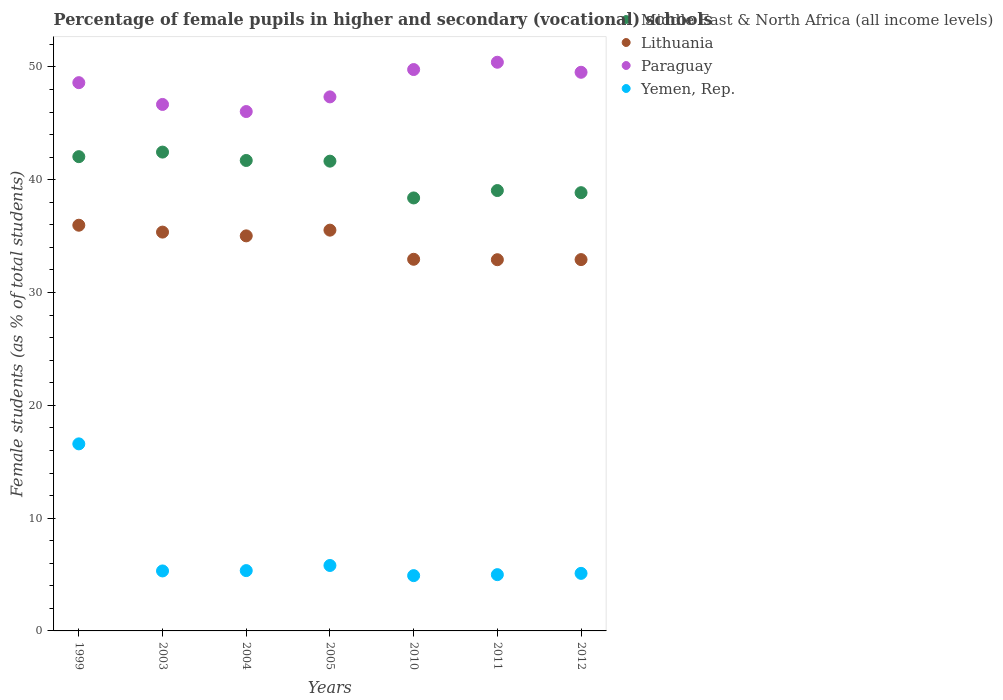What is the percentage of female pupils in higher and secondary schools in Middle East & North Africa (all income levels) in 2003?
Ensure brevity in your answer.  42.45. Across all years, what is the maximum percentage of female pupils in higher and secondary schools in Yemen, Rep.?
Offer a terse response. 16.58. Across all years, what is the minimum percentage of female pupils in higher and secondary schools in Middle East & North Africa (all income levels)?
Your answer should be compact. 38.39. In which year was the percentage of female pupils in higher and secondary schools in Lithuania minimum?
Keep it short and to the point. 2011. What is the total percentage of female pupils in higher and secondary schools in Lithuania in the graph?
Give a very brief answer. 240.66. What is the difference between the percentage of female pupils in higher and secondary schools in Middle East & North Africa (all income levels) in 2003 and that in 2011?
Provide a short and direct response. 3.41. What is the difference between the percentage of female pupils in higher and secondary schools in Middle East & North Africa (all income levels) in 1999 and the percentage of female pupils in higher and secondary schools in Paraguay in 2010?
Make the answer very short. -7.72. What is the average percentage of female pupils in higher and secondary schools in Middle East & North Africa (all income levels) per year?
Your response must be concise. 40.59. In the year 2003, what is the difference between the percentage of female pupils in higher and secondary schools in Middle East & North Africa (all income levels) and percentage of female pupils in higher and secondary schools in Paraguay?
Your answer should be very brief. -4.22. In how many years, is the percentage of female pupils in higher and secondary schools in Lithuania greater than 40 %?
Give a very brief answer. 0. What is the ratio of the percentage of female pupils in higher and secondary schools in Middle East & North Africa (all income levels) in 2003 to that in 2012?
Offer a terse response. 1.09. Is the percentage of female pupils in higher and secondary schools in Middle East & North Africa (all income levels) in 2003 less than that in 2005?
Ensure brevity in your answer.  No. What is the difference between the highest and the second highest percentage of female pupils in higher and secondary schools in Lithuania?
Make the answer very short. 0.44. What is the difference between the highest and the lowest percentage of female pupils in higher and secondary schools in Paraguay?
Make the answer very short. 4.37. Is it the case that in every year, the sum of the percentage of female pupils in higher and secondary schools in Middle East & North Africa (all income levels) and percentage of female pupils in higher and secondary schools in Lithuania  is greater than the sum of percentage of female pupils in higher and secondary schools in Yemen, Rep. and percentage of female pupils in higher and secondary schools in Paraguay?
Offer a terse response. No. Does the percentage of female pupils in higher and secondary schools in Lithuania monotonically increase over the years?
Provide a succinct answer. No. Is the percentage of female pupils in higher and secondary schools in Middle East & North Africa (all income levels) strictly greater than the percentage of female pupils in higher and secondary schools in Lithuania over the years?
Keep it short and to the point. Yes. How many years are there in the graph?
Offer a very short reply. 7. Does the graph contain any zero values?
Keep it short and to the point. No. Does the graph contain grids?
Offer a very short reply. No. Where does the legend appear in the graph?
Offer a terse response. Top right. How many legend labels are there?
Give a very brief answer. 4. How are the legend labels stacked?
Give a very brief answer. Vertical. What is the title of the graph?
Offer a very short reply. Percentage of female pupils in higher and secondary (vocational) schools. Does "Mexico" appear as one of the legend labels in the graph?
Your response must be concise. No. What is the label or title of the X-axis?
Provide a short and direct response. Years. What is the label or title of the Y-axis?
Your response must be concise. Female students (as % of total students). What is the Female students (as % of total students) of Middle East & North Africa (all income levels) in 1999?
Ensure brevity in your answer.  42.05. What is the Female students (as % of total students) in Lithuania in 1999?
Offer a terse response. 35.97. What is the Female students (as % of total students) of Paraguay in 1999?
Keep it short and to the point. 48.61. What is the Female students (as % of total students) of Yemen, Rep. in 1999?
Give a very brief answer. 16.58. What is the Female students (as % of total students) of Middle East & North Africa (all income levels) in 2003?
Give a very brief answer. 42.45. What is the Female students (as % of total students) of Lithuania in 2003?
Offer a terse response. 35.36. What is the Female students (as % of total students) in Paraguay in 2003?
Provide a succinct answer. 46.68. What is the Female students (as % of total students) of Yemen, Rep. in 2003?
Your answer should be very brief. 5.32. What is the Female students (as % of total students) in Middle East & North Africa (all income levels) in 2004?
Offer a terse response. 41.71. What is the Female students (as % of total students) of Lithuania in 2004?
Provide a short and direct response. 35.02. What is the Female students (as % of total students) of Paraguay in 2004?
Provide a succinct answer. 46.05. What is the Female students (as % of total students) in Yemen, Rep. in 2004?
Provide a short and direct response. 5.35. What is the Female students (as % of total students) of Middle East & North Africa (all income levels) in 2005?
Offer a terse response. 41.65. What is the Female students (as % of total students) of Lithuania in 2005?
Your answer should be compact. 35.53. What is the Female students (as % of total students) in Paraguay in 2005?
Your answer should be very brief. 47.35. What is the Female students (as % of total students) of Yemen, Rep. in 2005?
Your answer should be compact. 5.8. What is the Female students (as % of total students) in Middle East & North Africa (all income levels) in 2010?
Your answer should be compact. 38.39. What is the Female students (as % of total students) in Lithuania in 2010?
Your response must be concise. 32.95. What is the Female students (as % of total students) in Paraguay in 2010?
Offer a terse response. 49.77. What is the Female students (as % of total students) of Yemen, Rep. in 2010?
Provide a short and direct response. 4.9. What is the Female students (as % of total students) of Middle East & North Africa (all income levels) in 2011?
Ensure brevity in your answer.  39.04. What is the Female students (as % of total students) in Lithuania in 2011?
Your answer should be compact. 32.91. What is the Female students (as % of total students) of Paraguay in 2011?
Your answer should be very brief. 50.42. What is the Female students (as % of total students) in Yemen, Rep. in 2011?
Ensure brevity in your answer.  4.99. What is the Female students (as % of total students) in Middle East & North Africa (all income levels) in 2012?
Your answer should be compact. 38.85. What is the Female students (as % of total students) of Lithuania in 2012?
Provide a short and direct response. 32.92. What is the Female students (as % of total students) in Paraguay in 2012?
Give a very brief answer. 49.53. What is the Female students (as % of total students) in Yemen, Rep. in 2012?
Your answer should be very brief. 5.1. Across all years, what is the maximum Female students (as % of total students) of Middle East & North Africa (all income levels)?
Your answer should be very brief. 42.45. Across all years, what is the maximum Female students (as % of total students) in Lithuania?
Your response must be concise. 35.97. Across all years, what is the maximum Female students (as % of total students) of Paraguay?
Keep it short and to the point. 50.42. Across all years, what is the maximum Female students (as % of total students) in Yemen, Rep.?
Ensure brevity in your answer.  16.58. Across all years, what is the minimum Female students (as % of total students) in Middle East & North Africa (all income levels)?
Provide a short and direct response. 38.39. Across all years, what is the minimum Female students (as % of total students) of Lithuania?
Make the answer very short. 32.91. Across all years, what is the minimum Female students (as % of total students) of Paraguay?
Provide a succinct answer. 46.05. Across all years, what is the minimum Female students (as % of total students) of Yemen, Rep.?
Keep it short and to the point. 4.9. What is the total Female students (as % of total students) of Middle East & North Africa (all income levels) in the graph?
Provide a succinct answer. 284.13. What is the total Female students (as % of total students) in Lithuania in the graph?
Ensure brevity in your answer.  240.66. What is the total Female students (as % of total students) in Paraguay in the graph?
Your answer should be very brief. 338.39. What is the total Female students (as % of total students) in Yemen, Rep. in the graph?
Offer a very short reply. 48.05. What is the difference between the Female students (as % of total students) of Middle East & North Africa (all income levels) in 1999 and that in 2003?
Offer a very short reply. -0.4. What is the difference between the Female students (as % of total students) of Lithuania in 1999 and that in 2003?
Your response must be concise. 0.61. What is the difference between the Female students (as % of total students) of Paraguay in 1999 and that in 2003?
Offer a terse response. 1.93. What is the difference between the Female students (as % of total students) in Yemen, Rep. in 1999 and that in 2003?
Make the answer very short. 11.27. What is the difference between the Female students (as % of total students) in Middle East & North Africa (all income levels) in 1999 and that in 2004?
Provide a succinct answer. 0.34. What is the difference between the Female students (as % of total students) in Lithuania in 1999 and that in 2004?
Keep it short and to the point. 0.94. What is the difference between the Female students (as % of total students) of Paraguay in 1999 and that in 2004?
Keep it short and to the point. 2.56. What is the difference between the Female students (as % of total students) in Yemen, Rep. in 1999 and that in 2004?
Your answer should be very brief. 11.24. What is the difference between the Female students (as % of total students) of Middle East & North Africa (all income levels) in 1999 and that in 2005?
Offer a very short reply. 0.4. What is the difference between the Female students (as % of total students) of Lithuania in 1999 and that in 2005?
Give a very brief answer. 0.44. What is the difference between the Female students (as % of total students) in Paraguay in 1999 and that in 2005?
Offer a terse response. 1.26. What is the difference between the Female students (as % of total students) in Yemen, Rep. in 1999 and that in 2005?
Offer a terse response. 10.78. What is the difference between the Female students (as % of total students) of Middle East & North Africa (all income levels) in 1999 and that in 2010?
Your answer should be very brief. 3.66. What is the difference between the Female students (as % of total students) in Lithuania in 1999 and that in 2010?
Ensure brevity in your answer.  3.02. What is the difference between the Female students (as % of total students) of Paraguay in 1999 and that in 2010?
Provide a succinct answer. -1.16. What is the difference between the Female students (as % of total students) of Yemen, Rep. in 1999 and that in 2010?
Provide a short and direct response. 11.68. What is the difference between the Female students (as % of total students) of Middle East & North Africa (all income levels) in 1999 and that in 2011?
Provide a succinct answer. 3. What is the difference between the Female students (as % of total students) in Lithuania in 1999 and that in 2011?
Offer a very short reply. 3.06. What is the difference between the Female students (as % of total students) in Paraguay in 1999 and that in 2011?
Make the answer very short. -1.81. What is the difference between the Female students (as % of total students) of Yemen, Rep. in 1999 and that in 2011?
Offer a terse response. 11.59. What is the difference between the Female students (as % of total students) of Middle East & North Africa (all income levels) in 1999 and that in 2012?
Provide a short and direct response. 3.19. What is the difference between the Female students (as % of total students) in Lithuania in 1999 and that in 2012?
Your response must be concise. 3.05. What is the difference between the Female students (as % of total students) in Paraguay in 1999 and that in 2012?
Keep it short and to the point. -0.92. What is the difference between the Female students (as % of total students) of Yemen, Rep. in 1999 and that in 2012?
Provide a succinct answer. 11.48. What is the difference between the Female students (as % of total students) in Middle East & North Africa (all income levels) in 2003 and that in 2004?
Offer a terse response. 0.74. What is the difference between the Female students (as % of total students) in Lithuania in 2003 and that in 2004?
Provide a short and direct response. 0.33. What is the difference between the Female students (as % of total students) in Paraguay in 2003 and that in 2004?
Provide a succinct answer. 0.63. What is the difference between the Female students (as % of total students) in Yemen, Rep. in 2003 and that in 2004?
Offer a terse response. -0.03. What is the difference between the Female students (as % of total students) in Middle East & North Africa (all income levels) in 2003 and that in 2005?
Give a very brief answer. 0.8. What is the difference between the Female students (as % of total students) of Lithuania in 2003 and that in 2005?
Provide a succinct answer. -0.17. What is the difference between the Female students (as % of total students) of Paraguay in 2003 and that in 2005?
Your answer should be very brief. -0.67. What is the difference between the Female students (as % of total students) in Yemen, Rep. in 2003 and that in 2005?
Your answer should be very brief. -0.48. What is the difference between the Female students (as % of total students) in Middle East & North Africa (all income levels) in 2003 and that in 2010?
Offer a very short reply. 4.06. What is the difference between the Female students (as % of total students) in Lithuania in 2003 and that in 2010?
Ensure brevity in your answer.  2.41. What is the difference between the Female students (as % of total students) of Paraguay in 2003 and that in 2010?
Provide a short and direct response. -3.09. What is the difference between the Female students (as % of total students) of Yemen, Rep. in 2003 and that in 2010?
Provide a succinct answer. 0.42. What is the difference between the Female students (as % of total students) in Middle East & North Africa (all income levels) in 2003 and that in 2011?
Provide a succinct answer. 3.41. What is the difference between the Female students (as % of total students) in Lithuania in 2003 and that in 2011?
Offer a very short reply. 2.45. What is the difference between the Female students (as % of total students) of Paraguay in 2003 and that in 2011?
Make the answer very short. -3.74. What is the difference between the Female students (as % of total students) of Yemen, Rep. in 2003 and that in 2011?
Make the answer very short. 0.33. What is the difference between the Female students (as % of total students) of Middle East & North Africa (all income levels) in 2003 and that in 2012?
Make the answer very short. 3.6. What is the difference between the Female students (as % of total students) of Lithuania in 2003 and that in 2012?
Make the answer very short. 2.44. What is the difference between the Female students (as % of total students) of Paraguay in 2003 and that in 2012?
Offer a terse response. -2.85. What is the difference between the Female students (as % of total students) in Yemen, Rep. in 2003 and that in 2012?
Make the answer very short. 0.22. What is the difference between the Female students (as % of total students) in Middle East & North Africa (all income levels) in 2004 and that in 2005?
Ensure brevity in your answer.  0.06. What is the difference between the Female students (as % of total students) in Lithuania in 2004 and that in 2005?
Provide a succinct answer. -0.51. What is the difference between the Female students (as % of total students) of Paraguay in 2004 and that in 2005?
Your answer should be very brief. -1.3. What is the difference between the Female students (as % of total students) of Yemen, Rep. in 2004 and that in 2005?
Provide a succinct answer. -0.45. What is the difference between the Female students (as % of total students) of Middle East & North Africa (all income levels) in 2004 and that in 2010?
Your response must be concise. 3.32. What is the difference between the Female students (as % of total students) in Lithuania in 2004 and that in 2010?
Ensure brevity in your answer.  2.08. What is the difference between the Female students (as % of total students) in Paraguay in 2004 and that in 2010?
Your answer should be compact. -3.72. What is the difference between the Female students (as % of total students) in Yemen, Rep. in 2004 and that in 2010?
Give a very brief answer. 0.45. What is the difference between the Female students (as % of total students) in Middle East & North Africa (all income levels) in 2004 and that in 2011?
Your response must be concise. 2.67. What is the difference between the Female students (as % of total students) in Lithuania in 2004 and that in 2011?
Your answer should be very brief. 2.11. What is the difference between the Female students (as % of total students) of Paraguay in 2004 and that in 2011?
Give a very brief answer. -4.37. What is the difference between the Female students (as % of total students) of Yemen, Rep. in 2004 and that in 2011?
Offer a terse response. 0.36. What is the difference between the Female students (as % of total students) of Middle East & North Africa (all income levels) in 2004 and that in 2012?
Offer a terse response. 2.86. What is the difference between the Female students (as % of total students) of Lithuania in 2004 and that in 2012?
Provide a succinct answer. 2.1. What is the difference between the Female students (as % of total students) in Paraguay in 2004 and that in 2012?
Offer a terse response. -3.48. What is the difference between the Female students (as % of total students) in Yemen, Rep. in 2004 and that in 2012?
Give a very brief answer. 0.25. What is the difference between the Female students (as % of total students) in Middle East & North Africa (all income levels) in 2005 and that in 2010?
Your response must be concise. 3.26. What is the difference between the Female students (as % of total students) of Lithuania in 2005 and that in 2010?
Your answer should be compact. 2.58. What is the difference between the Female students (as % of total students) of Paraguay in 2005 and that in 2010?
Offer a very short reply. -2.42. What is the difference between the Female students (as % of total students) in Yemen, Rep. in 2005 and that in 2010?
Keep it short and to the point. 0.9. What is the difference between the Female students (as % of total students) in Middle East & North Africa (all income levels) in 2005 and that in 2011?
Make the answer very short. 2.61. What is the difference between the Female students (as % of total students) of Lithuania in 2005 and that in 2011?
Your response must be concise. 2.62. What is the difference between the Female students (as % of total students) of Paraguay in 2005 and that in 2011?
Your answer should be compact. -3.07. What is the difference between the Female students (as % of total students) in Yemen, Rep. in 2005 and that in 2011?
Keep it short and to the point. 0.81. What is the difference between the Female students (as % of total students) in Middle East & North Africa (all income levels) in 2005 and that in 2012?
Provide a short and direct response. 2.8. What is the difference between the Female students (as % of total students) of Lithuania in 2005 and that in 2012?
Offer a terse response. 2.61. What is the difference between the Female students (as % of total students) of Paraguay in 2005 and that in 2012?
Ensure brevity in your answer.  -2.18. What is the difference between the Female students (as % of total students) of Yemen, Rep. in 2005 and that in 2012?
Provide a short and direct response. 0.7. What is the difference between the Female students (as % of total students) of Middle East & North Africa (all income levels) in 2010 and that in 2011?
Your response must be concise. -0.66. What is the difference between the Female students (as % of total students) of Lithuania in 2010 and that in 2011?
Provide a short and direct response. 0.04. What is the difference between the Female students (as % of total students) of Paraguay in 2010 and that in 2011?
Ensure brevity in your answer.  -0.65. What is the difference between the Female students (as % of total students) in Yemen, Rep. in 2010 and that in 2011?
Offer a very short reply. -0.09. What is the difference between the Female students (as % of total students) in Middle East & North Africa (all income levels) in 2010 and that in 2012?
Keep it short and to the point. -0.47. What is the difference between the Female students (as % of total students) in Lithuania in 2010 and that in 2012?
Offer a very short reply. 0.03. What is the difference between the Female students (as % of total students) in Paraguay in 2010 and that in 2012?
Your response must be concise. 0.24. What is the difference between the Female students (as % of total students) of Yemen, Rep. in 2010 and that in 2012?
Your answer should be compact. -0.2. What is the difference between the Female students (as % of total students) of Middle East & North Africa (all income levels) in 2011 and that in 2012?
Give a very brief answer. 0.19. What is the difference between the Female students (as % of total students) in Lithuania in 2011 and that in 2012?
Provide a short and direct response. -0.01. What is the difference between the Female students (as % of total students) of Paraguay in 2011 and that in 2012?
Offer a terse response. 0.89. What is the difference between the Female students (as % of total students) of Yemen, Rep. in 2011 and that in 2012?
Your answer should be very brief. -0.11. What is the difference between the Female students (as % of total students) in Middle East & North Africa (all income levels) in 1999 and the Female students (as % of total students) in Lithuania in 2003?
Offer a very short reply. 6.69. What is the difference between the Female students (as % of total students) in Middle East & North Africa (all income levels) in 1999 and the Female students (as % of total students) in Paraguay in 2003?
Provide a succinct answer. -4.63. What is the difference between the Female students (as % of total students) of Middle East & North Africa (all income levels) in 1999 and the Female students (as % of total students) of Yemen, Rep. in 2003?
Your answer should be very brief. 36.73. What is the difference between the Female students (as % of total students) of Lithuania in 1999 and the Female students (as % of total students) of Paraguay in 2003?
Make the answer very short. -10.71. What is the difference between the Female students (as % of total students) in Lithuania in 1999 and the Female students (as % of total students) in Yemen, Rep. in 2003?
Keep it short and to the point. 30.65. What is the difference between the Female students (as % of total students) of Paraguay in 1999 and the Female students (as % of total students) of Yemen, Rep. in 2003?
Provide a succinct answer. 43.29. What is the difference between the Female students (as % of total students) in Middle East & North Africa (all income levels) in 1999 and the Female students (as % of total students) in Lithuania in 2004?
Provide a short and direct response. 7.02. What is the difference between the Female students (as % of total students) of Middle East & North Africa (all income levels) in 1999 and the Female students (as % of total students) of Paraguay in 2004?
Provide a succinct answer. -4. What is the difference between the Female students (as % of total students) of Middle East & North Africa (all income levels) in 1999 and the Female students (as % of total students) of Yemen, Rep. in 2004?
Give a very brief answer. 36.7. What is the difference between the Female students (as % of total students) in Lithuania in 1999 and the Female students (as % of total students) in Paraguay in 2004?
Ensure brevity in your answer.  -10.08. What is the difference between the Female students (as % of total students) in Lithuania in 1999 and the Female students (as % of total students) in Yemen, Rep. in 2004?
Make the answer very short. 30.62. What is the difference between the Female students (as % of total students) in Paraguay in 1999 and the Female students (as % of total students) in Yemen, Rep. in 2004?
Provide a short and direct response. 43.26. What is the difference between the Female students (as % of total students) of Middle East & North Africa (all income levels) in 1999 and the Female students (as % of total students) of Lithuania in 2005?
Your answer should be compact. 6.52. What is the difference between the Female students (as % of total students) of Middle East & North Africa (all income levels) in 1999 and the Female students (as % of total students) of Paraguay in 2005?
Ensure brevity in your answer.  -5.3. What is the difference between the Female students (as % of total students) of Middle East & North Africa (all income levels) in 1999 and the Female students (as % of total students) of Yemen, Rep. in 2005?
Give a very brief answer. 36.24. What is the difference between the Female students (as % of total students) in Lithuania in 1999 and the Female students (as % of total students) in Paraguay in 2005?
Offer a very short reply. -11.38. What is the difference between the Female students (as % of total students) in Lithuania in 1999 and the Female students (as % of total students) in Yemen, Rep. in 2005?
Offer a very short reply. 30.17. What is the difference between the Female students (as % of total students) of Paraguay in 1999 and the Female students (as % of total students) of Yemen, Rep. in 2005?
Your answer should be compact. 42.8. What is the difference between the Female students (as % of total students) of Middle East & North Africa (all income levels) in 1999 and the Female students (as % of total students) of Lithuania in 2010?
Keep it short and to the point. 9.1. What is the difference between the Female students (as % of total students) of Middle East & North Africa (all income levels) in 1999 and the Female students (as % of total students) of Paraguay in 2010?
Keep it short and to the point. -7.72. What is the difference between the Female students (as % of total students) in Middle East & North Africa (all income levels) in 1999 and the Female students (as % of total students) in Yemen, Rep. in 2010?
Ensure brevity in your answer.  37.14. What is the difference between the Female students (as % of total students) of Lithuania in 1999 and the Female students (as % of total students) of Paraguay in 2010?
Give a very brief answer. -13.8. What is the difference between the Female students (as % of total students) in Lithuania in 1999 and the Female students (as % of total students) in Yemen, Rep. in 2010?
Offer a terse response. 31.07. What is the difference between the Female students (as % of total students) of Paraguay in 1999 and the Female students (as % of total students) of Yemen, Rep. in 2010?
Your answer should be compact. 43.7. What is the difference between the Female students (as % of total students) in Middle East & North Africa (all income levels) in 1999 and the Female students (as % of total students) in Lithuania in 2011?
Keep it short and to the point. 9.14. What is the difference between the Female students (as % of total students) in Middle East & North Africa (all income levels) in 1999 and the Female students (as % of total students) in Paraguay in 2011?
Offer a very short reply. -8.37. What is the difference between the Female students (as % of total students) of Middle East & North Africa (all income levels) in 1999 and the Female students (as % of total students) of Yemen, Rep. in 2011?
Keep it short and to the point. 37.06. What is the difference between the Female students (as % of total students) of Lithuania in 1999 and the Female students (as % of total students) of Paraguay in 2011?
Keep it short and to the point. -14.45. What is the difference between the Female students (as % of total students) in Lithuania in 1999 and the Female students (as % of total students) in Yemen, Rep. in 2011?
Your answer should be compact. 30.98. What is the difference between the Female students (as % of total students) in Paraguay in 1999 and the Female students (as % of total students) in Yemen, Rep. in 2011?
Keep it short and to the point. 43.62. What is the difference between the Female students (as % of total students) in Middle East & North Africa (all income levels) in 1999 and the Female students (as % of total students) in Lithuania in 2012?
Ensure brevity in your answer.  9.13. What is the difference between the Female students (as % of total students) of Middle East & North Africa (all income levels) in 1999 and the Female students (as % of total students) of Paraguay in 2012?
Ensure brevity in your answer.  -7.48. What is the difference between the Female students (as % of total students) in Middle East & North Africa (all income levels) in 1999 and the Female students (as % of total students) in Yemen, Rep. in 2012?
Offer a terse response. 36.94. What is the difference between the Female students (as % of total students) in Lithuania in 1999 and the Female students (as % of total students) in Paraguay in 2012?
Your response must be concise. -13.56. What is the difference between the Female students (as % of total students) in Lithuania in 1999 and the Female students (as % of total students) in Yemen, Rep. in 2012?
Offer a very short reply. 30.87. What is the difference between the Female students (as % of total students) in Paraguay in 1999 and the Female students (as % of total students) in Yemen, Rep. in 2012?
Offer a very short reply. 43.5. What is the difference between the Female students (as % of total students) in Middle East & North Africa (all income levels) in 2003 and the Female students (as % of total students) in Lithuania in 2004?
Keep it short and to the point. 7.43. What is the difference between the Female students (as % of total students) in Middle East & North Africa (all income levels) in 2003 and the Female students (as % of total students) in Paraguay in 2004?
Ensure brevity in your answer.  -3.6. What is the difference between the Female students (as % of total students) of Middle East & North Africa (all income levels) in 2003 and the Female students (as % of total students) of Yemen, Rep. in 2004?
Ensure brevity in your answer.  37.1. What is the difference between the Female students (as % of total students) in Lithuania in 2003 and the Female students (as % of total students) in Paraguay in 2004?
Ensure brevity in your answer.  -10.69. What is the difference between the Female students (as % of total students) of Lithuania in 2003 and the Female students (as % of total students) of Yemen, Rep. in 2004?
Offer a very short reply. 30.01. What is the difference between the Female students (as % of total students) of Paraguay in 2003 and the Female students (as % of total students) of Yemen, Rep. in 2004?
Your answer should be compact. 41.33. What is the difference between the Female students (as % of total students) in Middle East & North Africa (all income levels) in 2003 and the Female students (as % of total students) in Lithuania in 2005?
Make the answer very short. 6.92. What is the difference between the Female students (as % of total students) in Middle East & North Africa (all income levels) in 2003 and the Female students (as % of total students) in Paraguay in 2005?
Give a very brief answer. -4.89. What is the difference between the Female students (as % of total students) in Middle East & North Africa (all income levels) in 2003 and the Female students (as % of total students) in Yemen, Rep. in 2005?
Your answer should be compact. 36.65. What is the difference between the Female students (as % of total students) in Lithuania in 2003 and the Female students (as % of total students) in Paraguay in 2005?
Provide a succinct answer. -11.99. What is the difference between the Female students (as % of total students) of Lithuania in 2003 and the Female students (as % of total students) of Yemen, Rep. in 2005?
Your answer should be very brief. 29.56. What is the difference between the Female students (as % of total students) of Paraguay in 2003 and the Female students (as % of total students) of Yemen, Rep. in 2005?
Provide a short and direct response. 40.87. What is the difference between the Female students (as % of total students) in Middle East & North Africa (all income levels) in 2003 and the Female students (as % of total students) in Lithuania in 2010?
Provide a succinct answer. 9.5. What is the difference between the Female students (as % of total students) in Middle East & North Africa (all income levels) in 2003 and the Female students (as % of total students) in Paraguay in 2010?
Ensure brevity in your answer.  -7.32. What is the difference between the Female students (as % of total students) of Middle East & North Africa (all income levels) in 2003 and the Female students (as % of total students) of Yemen, Rep. in 2010?
Offer a very short reply. 37.55. What is the difference between the Female students (as % of total students) of Lithuania in 2003 and the Female students (as % of total students) of Paraguay in 2010?
Give a very brief answer. -14.41. What is the difference between the Female students (as % of total students) of Lithuania in 2003 and the Female students (as % of total students) of Yemen, Rep. in 2010?
Give a very brief answer. 30.45. What is the difference between the Female students (as % of total students) of Paraguay in 2003 and the Female students (as % of total students) of Yemen, Rep. in 2010?
Provide a short and direct response. 41.77. What is the difference between the Female students (as % of total students) in Middle East & North Africa (all income levels) in 2003 and the Female students (as % of total students) in Lithuania in 2011?
Your response must be concise. 9.54. What is the difference between the Female students (as % of total students) in Middle East & North Africa (all income levels) in 2003 and the Female students (as % of total students) in Paraguay in 2011?
Offer a very short reply. -7.97. What is the difference between the Female students (as % of total students) of Middle East & North Africa (all income levels) in 2003 and the Female students (as % of total students) of Yemen, Rep. in 2011?
Offer a terse response. 37.46. What is the difference between the Female students (as % of total students) in Lithuania in 2003 and the Female students (as % of total students) in Paraguay in 2011?
Provide a succinct answer. -15.06. What is the difference between the Female students (as % of total students) of Lithuania in 2003 and the Female students (as % of total students) of Yemen, Rep. in 2011?
Your answer should be compact. 30.37. What is the difference between the Female students (as % of total students) of Paraguay in 2003 and the Female students (as % of total students) of Yemen, Rep. in 2011?
Give a very brief answer. 41.69. What is the difference between the Female students (as % of total students) in Middle East & North Africa (all income levels) in 2003 and the Female students (as % of total students) in Lithuania in 2012?
Make the answer very short. 9.53. What is the difference between the Female students (as % of total students) in Middle East & North Africa (all income levels) in 2003 and the Female students (as % of total students) in Paraguay in 2012?
Keep it short and to the point. -7.08. What is the difference between the Female students (as % of total students) of Middle East & North Africa (all income levels) in 2003 and the Female students (as % of total students) of Yemen, Rep. in 2012?
Ensure brevity in your answer.  37.35. What is the difference between the Female students (as % of total students) of Lithuania in 2003 and the Female students (as % of total students) of Paraguay in 2012?
Offer a terse response. -14.17. What is the difference between the Female students (as % of total students) in Lithuania in 2003 and the Female students (as % of total students) in Yemen, Rep. in 2012?
Give a very brief answer. 30.25. What is the difference between the Female students (as % of total students) in Paraguay in 2003 and the Female students (as % of total students) in Yemen, Rep. in 2012?
Offer a very short reply. 41.57. What is the difference between the Female students (as % of total students) in Middle East & North Africa (all income levels) in 2004 and the Female students (as % of total students) in Lithuania in 2005?
Your answer should be very brief. 6.18. What is the difference between the Female students (as % of total students) of Middle East & North Africa (all income levels) in 2004 and the Female students (as % of total students) of Paraguay in 2005?
Give a very brief answer. -5.64. What is the difference between the Female students (as % of total students) in Middle East & North Africa (all income levels) in 2004 and the Female students (as % of total students) in Yemen, Rep. in 2005?
Offer a very short reply. 35.91. What is the difference between the Female students (as % of total students) in Lithuania in 2004 and the Female students (as % of total students) in Paraguay in 2005?
Offer a very short reply. -12.32. What is the difference between the Female students (as % of total students) of Lithuania in 2004 and the Female students (as % of total students) of Yemen, Rep. in 2005?
Your response must be concise. 29.22. What is the difference between the Female students (as % of total students) in Paraguay in 2004 and the Female students (as % of total students) in Yemen, Rep. in 2005?
Offer a very short reply. 40.24. What is the difference between the Female students (as % of total students) of Middle East & North Africa (all income levels) in 2004 and the Female students (as % of total students) of Lithuania in 2010?
Your answer should be very brief. 8.76. What is the difference between the Female students (as % of total students) of Middle East & North Africa (all income levels) in 2004 and the Female students (as % of total students) of Paraguay in 2010?
Offer a terse response. -8.06. What is the difference between the Female students (as % of total students) in Middle East & North Africa (all income levels) in 2004 and the Female students (as % of total students) in Yemen, Rep. in 2010?
Offer a very short reply. 36.81. What is the difference between the Female students (as % of total students) in Lithuania in 2004 and the Female students (as % of total students) in Paraguay in 2010?
Your response must be concise. -14.75. What is the difference between the Female students (as % of total students) in Lithuania in 2004 and the Female students (as % of total students) in Yemen, Rep. in 2010?
Offer a terse response. 30.12. What is the difference between the Female students (as % of total students) in Paraguay in 2004 and the Female students (as % of total students) in Yemen, Rep. in 2010?
Your answer should be very brief. 41.14. What is the difference between the Female students (as % of total students) in Middle East & North Africa (all income levels) in 2004 and the Female students (as % of total students) in Lithuania in 2011?
Provide a short and direct response. 8.8. What is the difference between the Female students (as % of total students) in Middle East & North Africa (all income levels) in 2004 and the Female students (as % of total students) in Paraguay in 2011?
Provide a short and direct response. -8.71. What is the difference between the Female students (as % of total students) of Middle East & North Africa (all income levels) in 2004 and the Female students (as % of total students) of Yemen, Rep. in 2011?
Provide a short and direct response. 36.72. What is the difference between the Female students (as % of total students) in Lithuania in 2004 and the Female students (as % of total students) in Paraguay in 2011?
Keep it short and to the point. -15.39. What is the difference between the Female students (as % of total students) in Lithuania in 2004 and the Female students (as % of total students) in Yemen, Rep. in 2011?
Provide a succinct answer. 30.03. What is the difference between the Female students (as % of total students) in Paraguay in 2004 and the Female students (as % of total students) in Yemen, Rep. in 2011?
Make the answer very short. 41.06. What is the difference between the Female students (as % of total students) in Middle East & North Africa (all income levels) in 2004 and the Female students (as % of total students) in Lithuania in 2012?
Your answer should be very brief. 8.79. What is the difference between the Female students (as % of total students) of Middle East & North Africa (all income levels) in 2004 and the Female students (as % of total students) of Paraguay in 2012?
Provide a succinct answer. -7.82. What is the difference between the Female students (as % of total students) in Middle East & North Africa (all income levels) in 2004 and the Female students (as % of total students) in Yemen, Rep. in 2012?
Your answer should be very brief. 36.61. What is the difference between the Female students (as % of total students) of Lithuania in 2004 and the Female students (as % of total students) of Paraguay in 2012?
Your answer should be compact. -14.5. What is the difference between the Female students (as % of total students) in Lithuania in 2004 and the Female students (as % of total students) in Yemen, Rep. in 2012?
Provide a short and direct response. 29.92. What is the difference between the Female students (as % of total students) of Paraguay in 2004 and the Female students (as % of total students) of Yemen, Rep. in 2012?
Give a very brief answer. 40.94. What is the difference between the Female students (as % of total students) in Middle East & North Africa (all income levels) in 2005 and the Female students (as % of total students) in Lithuania in 2010?
Keep it short and to the point. 8.7. What is the difference between the Female students (as % of total students) of Middle East & North Africa (all income levels) in 2005 and the Female students (as % of total students) of Paraguay in 2010?
Your answer should be very brief. -8.12. What is the difference between the Female students (as % of total students) of Middle East & North Africa (all income levels) in 2005 and the Female students (as % of total students) of Yemen, Rep. in 2010?
Your answer should be compact. 36.74. What is the difference between the Female students (as % of total students) in Lithuania in 2005 and the Female students (as % of total students) in Paraguay in 2010?
Give a very brief answer. -14.24. What is the difference between the Female students (as % of total students) in Lithuania in 2005 and the Female students (as % of total students) in Yemen, Rep. in 2010?
Provide a succinct answer. 30.63. What is the difference between the Female students (as % of total students) in Paraguay in 2005 and the Female students (as % of total students) in Yemen, Rep. in 2010?
Your answer should be compact. 42.44. What is the difference between the Female students (as % of total students) of Middle East & North Africa (all income levels) in 2005 and the Female students (as % of total students) of Lithuania in 2011?
Your answer should be compact. 8.74. What is the difference between the Female students (as % of total students) in Middle East & North Africa (all income levels) in 2005 and the Female students (as % of total students) in Paraguay in 2011?
Your response must be concise. -8.77. What is the difference between the Female students (as % of total students) of Middle East & North Africa (all income levels) in 2005 and the Female students (as % of total students) of Yemen, Rep. in 2011?
Ensure brevity in your answer.  36.66. What is the difference between the Female students (as % of total students) in Lithuania in 2005 and the Female students (as % of total students) in Paraguay in 2011?
Your answer should be very brief. -14.89. What is the difference between the Female students (as % of total students) in Lithuania in 2005 and the Female students (as % of total students) in Yemen, Rep. in 2011?
Offer a very short reply. 30.54. What is the difference between the Female students (as % of total students) of Paraguay in 2005 and the Female students (as % of total students) of Yemen, Rep. in 2011?
Provide a succinct answer. 42.36. What is the difference between the Female students (as % of total students) in Middle East & North Africa (all income levels) in 2005 and the Female students (as % of total students) in Lithuania in 2012?
Your answer should be very brief. 8.73. What is the difference between the Female students (as % of total students) of Middle East & North Africa (all income levels) in 2005 and the Female students (as % of total students) of Paraguay in 2012?
Give a very brief answer. -7.88. What is the difference between the Female students (as % of total students) of Middle East & North Africa (all income levels) in 2005 and the Female students (as % of total students) of Yemen, Rep. in 2012?
Your response must be concise. 36.54. What is the difference between the Female students (as % of total students) of Lithuania in 2005 and the Female students (as % of total students) of Paraguay in 2012?
Offer a very short reply. -14. What is the difference between the Female students (as % of total students) of Lithuania in 2005 and the Female students (as % of total students) of Yemen, Rep. in 2012?
Your answer should be very brief. 30.43. What is the difference between the Female students (as % of total students) of Paraguay in 2005 and the Female students (as % of total students) of Yemen, Rep. in 2012?
Provide a short and direct response. 42.24. What is the difference between the Female students (as % of total students) in Middle East & North Africa (all income levels) in 2010 and the Female students (as % of total students) in Lithuania in 2011?
Your answer should be very brief. 5.48. What is the difference between the Female students (as % of total students) in Middle East & North Africa (all income levels) in 2010 and the Female students (as % of total students) in Paraguay in 2011?
Your answer should be very brief. -12.03. What is the difference between the Female students (as % of total students) in Middle East & North Africa (all income levels) in 2010 and the Female students (as % of total students) in Yemen, Rep. in 2011?
Offer a terse response. 33.4. What is the difference between the Female students (as % of total students) of Lithuania in 2010 and the Female students (as % of total students) of Paraguay in 2011?
Give a very brief answer. -17.47. What is the difference between the Female students (as % of total students) in Lithuania in 2010 and the Female students (as % of total students) in Yemen, Rep. in 2011?
Give a very brief answer. 27.96. What is the difference between the Female students (as % of total students) of Paraguay in 2010 and the Female students (as % of total students) of Yemen, Rep. in 2011?
Provide a succinct answer. 44.78. What is the difference between the Female students (as % of total students) in Middle East & North Africa (all income levels) in 2010 and the Female students (as % of total students) in Lithuania in 2012?
Give a very brief answer. 5.47. What is the difference between the Female students (as % of total students) of Middle East & North Africa (all income levels) in 2010 and the Female students (as % of total students) of Paraguay in 2012?
Provide a succinct answer. -11.14. What is the difference between the Female students (as % of total students) of Middle East & North Africa (all income levels) in 2010 and the Female students (as % of total students) of Yemen, Rep. in 2012?
Your response must be concise. 33.28. What is the difference between the Female students (as % of total students) in Lithuania in 2010 and the Female students (as % of total students) in Paraguay in 2012?
Give a very brief answer. -16.58. What is the difference between the Female students (as % of total students) of Lithuania in 2010 and the Female students (as % of total students) of Yemen, Rep. in 2012?
Your response must be concise. 27.85. What is the difference between the Female students (as % of total students) in Paraguay in 2010 and the Female students (as % of total students) in Yemen, Rep. in 2012?
Offer a very short reply. 44.67. What is the difference between the Female students (as % of total students) in Middle East & North Africa (all income levels) in 2011 and the Female students (as % of total students) in Lithuania in 2012?
Provide a short and direct response. 6.12. What is the difference between the Female students (as % of total students) in Middle East & North Africa (all income levels) in 2011 and the Female students (as % of total students) in Paraguay in 2012?
Offer a very short reply. -10.49. What is the difference between the Female students (as % of total students) in Middle East & North Africa (all income levels) in 2011 and the Female students (as % of total students) in Yemen, Rep. in 2012?
Provide a short and direct response. 33.94. What is the difference between the Female students (as % of total students) of Lithuania in 2011 and the Female students (as % of total students) of Paraguay in 2012?
Your answer should be compact. -16.62. What is the difference between the Female students (as % of total students) in Lithuania in 2011 and the Female students (as % of total students) in Yemen, Rep. in 2012?
Give a very brief answer. 27.81. What is the difference between the Female students (as % of total students) in Paraguay in 2011 and the Female students (as % of total students) in Yemen, Rep. in 2012?
Your response must be concise. 45.31. What is the average Female students (as % of total students) in Middle East & North Africa (all income levels) per year?
Your answer should be compact. 40.59. What is the average Female students (as % of total students) of Lithuania per year?
Keep it short and to the point. 34.38. What is the average Female students (as % of total students) of Paraguay per year?
Your response must be concise. 48.34. What is the average Female students (as % of total students) of Yemen, Rep. per year?
Ensure brevity in your answer.  6.86. In the year 1999, what is the difference between the Female students (as % of total students) in Middle East & North Africa (all income levels) and Female students (as % of total students) in Lithuania?
Your answer should be very brief. 6.08. In the year 1999, what is the difference between the Female students (as % of total students) in Middle East & North Africa (all income levels) and Female students (as % of total students) in Paraguay?
Provide a succinct answer. -6.56. In the year 1999, what is the difference between the Female students (as % of total students) in Middle East & North Africa (all income levels) and Female students (as % of total students) in Yemen, Rep.?
Ensure brevity in your answer.  25.46. In the year 1999, what is the difference between the Female students (as % of total students) of Lithuania and Female students (as % of total students) of Paraguay?
Offer a very short reply. -12.64. In the year 1999, what is the difference between the Female students (as % of total students) in Lithuania and Female students (as % of total students) in Yemen, Rep.?
Provide a short and direct response. 19.38. In the year 1999, what is the difference between the Female students (as % of total students) in Paraguay and Female students (as % of total students) in Yemen, Rep.?
Ensure brevity in your answer.  32.02. In the year 2003, what is the difference between the Female students (as % of total students) in Middle East & North Africa (all income levels) and Female students (as % of total students) in Lithuania?
Your answer should be very brief. 7.09. In the year 2003, what is the difference between the Female students (as % of total students) in Middle East & North Africa (all income levels) and Female students (as % of total students) in Paraguay?
Ensure brevity in your answer.  -4.22. In the year 2003, what is the difference between the Female students (as % of total students) of Middle East & North Africa (all income levels) and Female students (as % of total students) of Yemen, Rep.?
Offer a terse response. 37.13. In the year 2003, what is the difference between the Female students (as % of total students) in Lithuania and Female students (as % of total students) in Paraguay?
Provide a short and direct response. -11.32. In the year 2003, what is the difference between the Female students (as % of total students) in Lithuania and Female students (as % of total students) in Yemen, Rep.?
Offer a terse response. 30.04. In the year 2003, what is the difference between the Female students (as % of total students) of Paraguay and Female students (as % of total students) of Yemen, Rep.?
Provide a short and direct response. 41.36. In the year 2004, what is the difference between the Female students (as % of total students) of Middle East & North Africa (all income levels) and Female students (as % of total students) of Lithuania?
Provide a succinct answer. 6.68. In the year 2004, what is the difference between the Female students (as % of total students) of Middle East & North Africa (all income levels) and Female students (as % of total students) of Paraguay?
Offer a very short reply. -4.34. In the year 2004, what is the difference between the Female students (as % of total students) in Middle East & North Africa (all income levels) and Female students (as % of total students) in Yemen, Rep.?
Give a very brief answer. 36.36. In the year 2004, what is the difference between the Female students (as % of total students) of Lithuania and Female students (as % of total students) of Paraguay?
Your response must be concise. -11.02. In the year 2004, what is the difference between the Female students (as % of total students) in Lithuania and Female students (as % of total students) in Yemen, Rep.?
Offer a terse response. 29.68. In the year 2004, what is the difference between the Female students (as % of total students) in Paraguay and Female students (as % of total students) in Yemen, Rep.?
Your response must be concise. 40.7. In the year 2005, what is the difference between the Female students (as % of total students) of Middle East & North Africa (all income levels) and Female students (as % of total students) of Lithuania?
Provide a succinct answer. 6.12. In the year 2005, what is the difference between the Female students (as % of total students) of Middle East & North Africa (all income levels) and Female students (as % of total students) of Paraguay?
Your answer should be very brief. -5.7. In the year 2005, what is the difference between the Female students (as % of total students) of Middle East & North Africa (all income levels) and Female students (as % of total students) of Yemen, Rep.?
Make the answer very short. 35.85. In the year 2005, what is the difference between the Female students (as % of total students) of Lithuania and Female students (as % of total students) of Paraguay?
Your answer should be compact. -11.81. In the year 2005, what is the difference between the Female students (as % of total students) of Lithuania and Female students (as % of total students) of Yemen, Rep.?
Ensure brevity in your answer.  29.73. In the year 2005, what is the difference between the Female students (as % of total students) of Paraguay and Female students (as % of total students) of Yemen, Rep.?
Your answer should be very brief. 41.54. In the year 2010, what is the difference between the Female students (as % of total students) of Middle East & North Africa (all income levels) and Female students (as % of total students) of Lithuania?
Provide a short and direct response. 5.44. In the year 2010, what is the difference between the Female students (as % of total students) in Middle East & North Africa (all income levels) and Female students (as % of total students) in Paraguay?
Provide a succinct answer. -11.38. In the year 2010, what is the difference between the Female students (as % of total students) of Middle East & North Africa (all income levels) and Female students (as % of total students) of Yemen, Rep.?
Make the answer very short. 33.48. In the year 2010, what is the difference between the Female students (as % of total students) in Lithuania and Female students (as % of total students) in Paraguay?
Offer a terse response. -16.82. In the year 2010, what is the difference between the Female students (as % of total students) in Lithuania and Female students (as % of total students) in Yemen, Rep.?
Provide a short and direct response. 28.05. In the year 2010, what is the difference between the Female students (as % of total students) of Paraguay and Female students (as % of total students) of Yemen, Rep.?
Make the answer very short. 44.87. In the year 2011, what is the difference between the Female students (as % of total students) in Middle East & North Africa (all income levels) and Female students (as % of total students) in Lithuania?
Your response must be concise. 6.13. In the year 2011, what is the difference between the Female students (as % of total students) of Middle East & North Africa (all income levels) and Female students (as % of total students) of Paraguay?
Give a very brief answer. -11.37. In the year 2011, what is the difference between the Female students (as % of total students) of Middle East & North Africa (all income levels) and Female students (as % of total students) of Yemen, Rep.?
Your answer should be very brief. 34.05. In the year 2011, what is the difference between the Female students (as % of total students) of Lithuania and Female students (as % of total students) of Paraguay?
Provide a succinct answer. -17.51. In the year 2011, what is the difference between the Female students (as % of total students) of Lithuania and Female students (as % of total students) of Yemen, Rep.?
Make the answer very short. 27.92. In the year 2011, what is the difference between the Female students (as % of total students) in Paraguay and Female students (as % of total students) in Yemen, Rep.?
Give a very brief answer. 45.43. In the year 2012, what is the difference between the Female students (as % of total students) in Middle East & North Africa (all income levels) and Female students (as % of total students) in Lithuania?
Offer a terse response. 5.93. In the year 2012, what is the difference between the Female students (as % of total students) in Middle East & North Africa (all income levels) and Female students (as % of total students) in Paraguay?
Give a very brief answer. -10.68. In the year 2012, what is the difference between the Female students (as % of total students) of Middle East & North Africa (all income levels) and Female students (as % of total students) of Yemen, Rep.?
Provide a succinct answer. 33.75. In the year 2012, what is the difference between the Female students (as % of total students) in Lithuania and Female students (as % of total students) in Paraguay?
Your answer should be very brief. -16.61. In the year 2012, what is the difference between the Female students (as % of total students) of Lithuania and Female students (as % of total students) of Yemen, Rep.?
Ensure brevity in your answer.  27.82. In the year 2012, what is the difference between the Female students (as % of total students) in Paraguay and Female students (as % of total students) in Yemen, Rep.?
Provide a succinct answer. 44.42. What is the ratio of the Female students (as % of total students) in Middle East & North Africa (all income levels) in 1999 to that in 2003?
Keep it short and to the point. 0.99. What is the ratio of the Female students (as % of total students) of Lithuania in 1999 to that in 2003?
Offer a terse response. 1.02. What is the ratio of the Female students (as % of total students) of Paraguay in 1999 to that in 2003?
Offer a very short reply. 1.04. What is the ratio of the Female students (as % of total students) in Yemen, Rep. in 1999 to that in 2003?
Offer a terse response. 3.12. What is the ratio of the Female students (as % of total students) of Lithuania in 1999 to that in 2004?
Give a very brief answer. 1.03. What is the ratio of the Female students (as % of total students) in Paraguay in 1999 to that in 2004?
Provide a short and direct response. 1.06. What is the ratio of the Female students (as % of total students) in Yemen, Rep. in 1999 to that in 2004?
Keep it short and to the point. 3.1. What is the ratio of the Female students (as % of total students) of Middle East & North Africa (all income levels) in 1999 to that in 2005?
Your answer should be very brief. 1.01. What is the ratio of the Female students (as % of total students) in Lithuania in 1999 to that in 2005?
Offer a terse response. 1.01. What is the ratio of the Female students (as % of total students) of Paraguay in 1999 to that in 2005?
Offer a very short reply. 1.03. What is the ratio of the Female students (as % of total students) of Yemen, Rep. in 1999 to that in 2005?
Make the answer very short. 2.86. What is the ratio of the Female students (as % of total students) in Middle East & North Africa (all income levels) in 1999 to that in 2010?
Ensure brevity in your answer.  1.1. What is the ratio of the Female students (as % of total students) in Lithuania in 1999 to that in 2010?
Offer a very short reply. 1.09. What is the ratio of the Female students (as % of total students) in Paraguay in 1999 to that in 2010?
Keep it short and to the point. 0.98. What is the ratio of the Female students (as % of total students) of Yemen, Rep. in 1999 to that in 2010?
Keep it short and to the point. 3.38. What is the ratio of the Female students (as % of total students) in Middle East & North Africa (all income levels) in 1999 to that in 2011?
Offer a very short reply. 1.08. What is the ratio of the Female students (as % of total students) of Lithuania in 1999 to that in 2011?
Your response must be concise. 1.09. What is the ratio of the Female students (as % of total students) in Paraguay in 1999 to that in 2011?
Your answer should be very brief. 0.96. What is the ratio of the Female students (as % of total students) in Yemen, Rep. in 1999 to that in 2011?
Keep it short and to the point. 3.32. What is the ratio of the Female students (as % of total students) in Middle East & North Africa (all income levels) in 1999 to that in 2012?
Provide a succinct answer. 1.08. What is the ratio of the Female students (as % of total students) in Lithuania in 1999 to that in 2012?
Keep it short and to the point. 1.09. What is the ratio of the Female students (as % of total students) in Paraguay in 1999 to that in 2012?
Offer a very short reply. 0.98. What is the ratio of the Female students (as % of total students) of Yemen, Rep. in 1999 to that in 2012?
Your response must be concise. 3.25. What is the ratio of the Female students (as % of total students) in Middle East & North Africa (all income levels) in 2003 to that in 2004?
Offer a terse response. 1.02. What is the ratio of the Female students (as % of total students) in Lithuania in 2003 to that in 2004?
Offer a terse response. 1.01. What is the ratio of the Female students (as % of total students) of Paraguay in 2003 to that in 2004?
Make the answer very short. 1.01. What is the ratio of the Female students (as % of total students) of Middle East & North Africa (all income levels) in 2003 to that in 2005?
Ensure brevity in your answer.  1.02. What is the ratio of the Female students (as % of total students) of Paraguay in 2003 to that in 2005?
Offer a terse response. 0.99. What is the ratio of the Female students (as % of total students) of Yemen, Rep. in 2003 to that in 2005?
Give a very brief answer. 0.92. What is the ratio of the Female students (as % of total students) of Middle East & North Africa (all income levels) in 2003 to that in 2010?
Provide a short and direct response. 1.11. What is the ratio of the Female students (as % of total students) in Lithuania in 2003 to that in 2010?
Offer a terse response. 1.07. What is the ratio of the Female students (as % of total students) in Paraguay in 2003 to that in 2010?
Give a very brief answer. 0.94. What is the ratio of the Female students (as % of total students) of Yemen, Rep. in 2003 to that in 2010?
Give a very brief answer. 1.08. What is the ratio of the Female students (as % of total students) in Middle East & North Africa (all income levels) in 2003 to that in 2011?
Your answer should be compact. 1.09. What is the ratio of the Female students (as % of total students) in Lithuania in 2003 to that in 2011?
Give a very brief answer. 1.07. What is the ratio of the Female students (as % of total students) in Paraguay in 2003 to that in 2011?
Provide a succinct answer. 0.93. What is the ratio of the Female students (as % of total students) in Yemen, Rep. in 2003 to that in 2011?
Keep it short and to the point. 1.07. What is the ratio of the Female students (as % of total students) of Middle East & North Africa (all income levels) in 2003 to that in 2012?
Your answer should be very brief. 1.09. What is the ratio of the Female students (as % of total students) of Lithuania in 2003 to that in 2012?
Your answer should be very brief. 1.07. What is the ratio of the Female students (as % of total students) of Paraguay in 2003 to that in 2012?
Provide a short and direct response. 0.94. What is the ratio of the Female students (as % of total students) of Yemen, Rep. in 2003 to that in 2012?
Keep it short and to the point. 1.04. What is the ratio of the Female students (as % of total students) in Lithuania in 2004 to that in 2005?
Offer a terse response. 0.99. What is the ratio of the Female students (as % of total students) of Paraguay in 2004 to that in 2005?
Provide a succinct answer. 0.97. What is the ratio of the Female students (as % of total students) in Yemen, Rep. in 2004 to that in 2005?
Ensure brevity in your answer.  0.92. What is the ratio of the Female students (as % of total students) in Middle East & North Africa (all income levels) in 2004 to that in 2010?
Ensure brevity in your answer.  1.09. What is the ratio of the Female students (as % of total students) in Lithuania in 2004 to that in 2010?
Make the answer very short. 1.06. What is the ratio of the Female students (as % of total students) of Paraguay in 2004 to that in 2010?
Keep it short and to the point. 0.93. What is the ratio of the Female students (as % of total students) of Yemen, Rep. in 2004 to that in 2010?
Give a very brief answer. 1.09. What is the ratio of the Female students (as % of total students) of Middle East & North Africa (all income levels) in 2004 to that in 2011?
Keep it short and to the point. 1.07. What is the ratio of the Female students (as % of total students) in Lithuania in 2004 to that in 2011?
Offer a very short reply. 1.06. What is the ratio of the Female students (as % of total students) of Paraguay in 2004 to that in 2011?
Give a very brief answer. 0.91. What is the ratio of the Female students (as % of total students) of Yemen, Rep. in 2004 to that in 2011?
Provide a succinct answer. 1.07. What is the ratio of the Female students (as % of total students) in Middle East & North Africa (all income levels) in 2004 to that in 2012?
Offer a terse response. 1.07. What is the ratio of the Female students (as % of total students) of Lithuania in 2004 to that in 2012?
Provide a succinct answer. 1.06. What is the ratio of the Female students (as % of total students) of Paraguay in 2004 to that in 2012?
Offer a very short reply. 0.93. What is the ratio of the Female students (as % of total students) in Yemen, Rep. in 2004 to that in 2012?
Provide a succinct answer. 1.05. What is the ratio of the Female students (as % of total students) of Middle East & North Africa (all income levels) in 2005 to that in 2010?
Offer a very short reply. 1.08. What is the ratio of the Female students (as % of total students) of Lithuania in 2005 to that in 2010?
Ensure brevity in your answer.  1.08. What is the ratio of the Female students (as % of total students) of Paraguay in 2005 to that in 2010?
Provide a short and direct response. 0.95. What is the ratio of the Female students (as % of total students) of Yemen, Rep. in 2005 to that in 2010?
Provide a succinct answer. 1.18. What is the ratio of the Female students (as % of total students) in Middle East & North Africa (all income levels) in 2005 to that in 2011?
Offer a very short reply. 1.07. What is the ratio of the Female students (as % of total students) of Lithuania in 2005 to that in 2011?
Offer a very short reply. 1.08. What is the ratio of the Female students (as % of total students) in Paraguay in 2005 to that in 2011?
Keep it short and to the point. 0.94. What is the ratio of the Female students (as % of total students) of Yemen, Rep. in 2005 to that in 2011?
Your answer should be compact. 1.16. What is the ratio of the Female students (as % of total students) of Middle East & North Africa (all income levels) in 2005 to that in 2012?
Offer a terse response. 1.07. What is the ratio of the Female students (as % of total students) of Lithuania in 2005 to that in 2012?
Ensure brevity in your answer.  1.08. What is the ratio of the Female students (as % of total students) in Paraguay in 2005 to that in 2012?
Your answer should be compact. 0.96. What is the ratio of the Female students (as % of total students) of Yemen, Rep. in 2005 to that in 2012?
Give a very brief answer. 1.14. What is the ratio of the Female students (as % of total students) in Middle East & North Africa (all income levels) in 2010 to that in 2011?
Provide a succinct answer. 0.98. What is the ratio of the Female students (as % of total students) in Lithuania in 2010 to that in 2011?
Your response must be concise. 1. What is the ratio of the Female students (as % of total students) of Paraguay in 2010 to that in 2011?
Your answer should be very brief. 0.99. What is the ratio of the Female students (as % of total students) of Yemen, Rep. in 2010 to that in 2011?
Your response must be concise. 0.98. What is the ratio of the Female students (as % of total students) of Paraguay in 2010 to that in 2012?
Offer a terse response. 1. What is the ratio of the Female students (as % of total students) of Yemen, Rep. in 2010 to that in 2012?
Offer a very short reply. 0.96. What is the ratio of the Female students (as % of total students) in Lithuania in 2011 to that in 2012?
Make the answer very short. 1. What is the ratio of the Female students (as % of total students) in Paraguay in 2011 to that in 2012?
Give a very brief answer. 1.02. What is the ratio of the Female students (as % of total students) in Yemen, Rep. in 2011 to that in 2012?
Make the answer very short. 0.98. What is the difference between the highest and the second highest Female students (as % of total students) in Middle East & North Africa (all income levels)?
Your response must be concise. 0.4. What is the difference between the highest and the second highest Female students (as % of total students) of Lithuania?
Your answer should be compact. 0.44. What is the difference between the highest and the second highest Female students (as % of total students) in Paraguay?
Offer a terse response. 0.65. What is the difference between the highest and the second highest Female students (as % of total students) of Yemen, Rep.?
Make the answer very short. 10.78. What is the difference between the highest and the lowest Female students (as % of total students) in Middle East & North Africa (all income levels)?
Make the answer very short. 4.06. What is the difference between the highest and the lowest Female students (as % of total students) in Lithuania?
Ensure brevity in your answer.  3.06. What is the difference between the highest and the lowest Female students (as % of total students) in Paraguay?
Your answer should be very brief. 4.37. What is the difference between the highest and the lowest Female students (as % of total students) in Yemen, Rep.?
Provide a short and direct response. 11.68. 